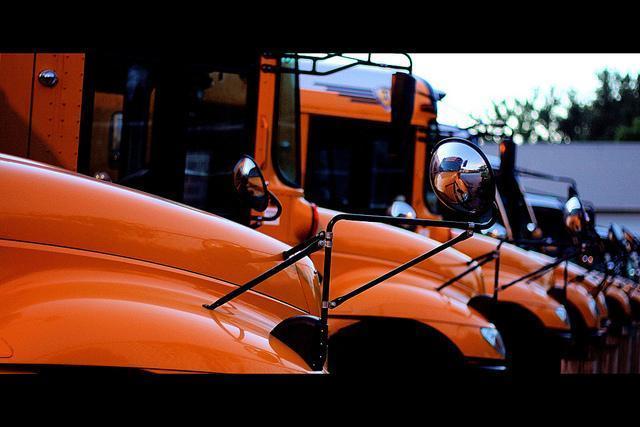How many buses do you see?
Give a very brief answer. 6. How many buses are there?
Give a very brief answer. 3. How many people are standing behind the counter?
Give a very brief answer. 0. 